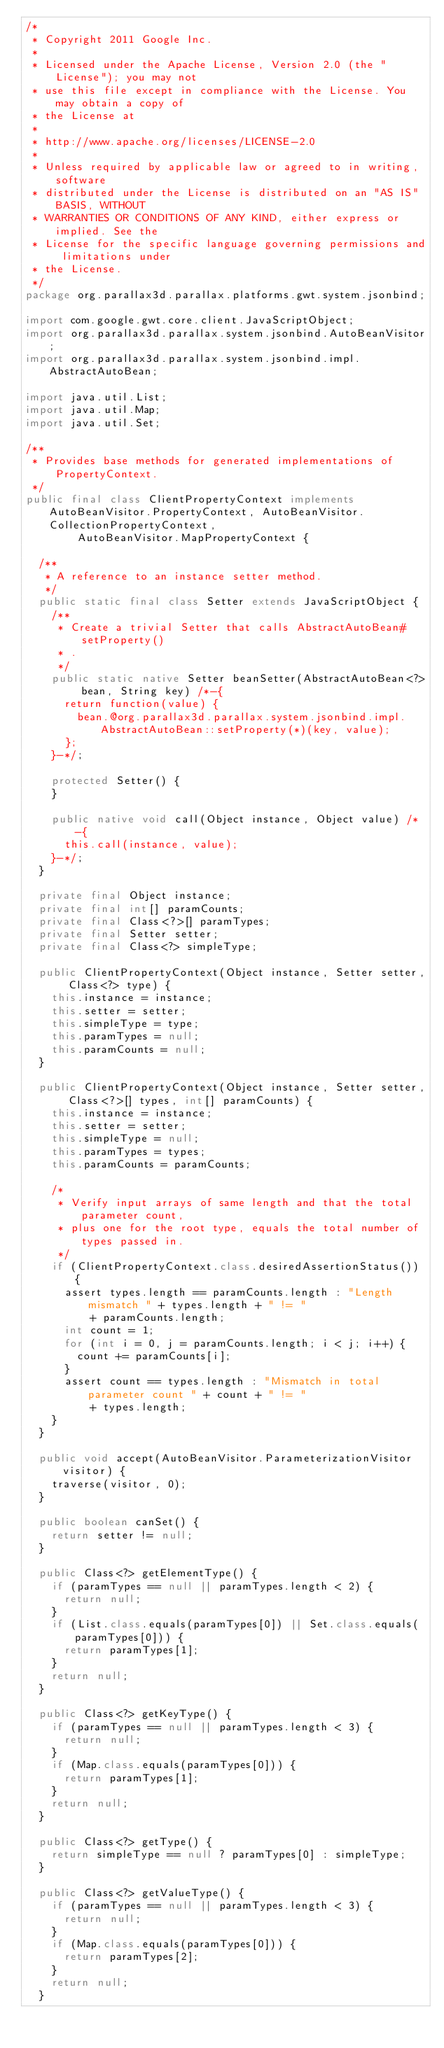Convert code to text. <code><loc_0><loc_0><loc_500><loc_500><_Java_>/*
 * Copyright 2011 Google Inc.
 *
 * Licensed under the Apache License, Version 2.0 (the "License"); you may not
 * use this file except in compliance with the License. You may obtain a copy of
 * the License at
 *
 * http://www.apache.org/licenses/LICENSE-2.0
 *
 * Unless required by applicable law or agreed to in writing, software
 * distributed under the License is distributed on an "AS IS" BASIS, WITHOUT
 * WARRANTIES OR CONDITIONS OF ANY KIND, either express or implied. See the
 * License for the specific language governing permissions and limitations under
 * the License.
 */
package org.parallax3d.parallax.platforms.gwt.system.jsonbind;

import com.google.gwt.core.client.JavaScriptObject;
import org.parallax3d.parallax.system.jsonbind.AutoBeanVisitor;
import org.parallax3d.parallax.system.jsonbind.impl.AbstractAutoBean;

import java.util.List;
import java.util.Map;
import java.util.Set;

/**
 * Provides base methods for generated implementations of PropertyContext.
 */
public final class ClientPropertyContext implements AutoBeanVisitor.PropertyContext, AutoBeanVisitor.CollectionPropertyContext,
        AutoBeanVisitor.MapPropertyContext {

  /**
   * A reference to an instance setter method.
   */
  public static final class Setter extends JavaScriptObject {
    /**
     * Create a trivial Setter that calls AbstractAutoBean#setProperty()
     * .
     */
    public static native Setter beanSetter(AbstractAutoBean<?> bean, String key) /*-{
      return function(value) {
        bean.@org.parallax3d.parallax.system.jsonbind.impl.AbstractAutoBean::setProperty(*)(key, value);
      };
    }-*/;

    protected Setter() {
    }

    public native void call(Object instance, Object value) /*-{
      this.call(instance, value);
    }-*/;
  }

  private final Object instance;
  private final int[] paramCounts;
  private final Class<?>[] paramTypes;
  private final Setter setter;
  private final Class<?> simpleType;

  public ClientPropertyContext(Object instance, Setter setter, Class<?> type) {
    this.instance = instance;
    this.setter = setter;
    this.simpleType = type;
    this.paramTypes = null;
    this.paramCounts = null;
  }

  public ClientPropertyContext(Object instance, Setter setter, Class<?>[] types, int[] paramCounts) {
    this.instance = instance;
    this.setter = setter;
    this.simpleType = null;
    this.paramTypes = types;
    this.paramCounts = paramCounts;

    /*
     * Verify input arrays of same length and that the total parameter count,
     * plus one for the root type, equals the total number of types passed in.
     */
    if (ClientPropertyContext.class.desiredAssertionStatus()) {
      assert types.length == paramCounts.length : "Length mismatch " + types.length + " != "
          + paramCounts.length;
      int count = 1;
      for (int i = 0, j = paramCounts.length; i < j; i++) {
        count += paramCounts[i];
      }
      assert count == types.length : "Mismatch in total parameter count " + count + " != "
          + types.length;
    }
  }

  public void accept(AutoBeanVisitor.ParameterizationVisitor visitor) {
    traverse(visitor, 0);
  }

  public boolean canSet() {
    return setter != null;
  }

  public Class<?> getElementType() {
    if (paramTypes == null || paramTypes.length < 2) {
      return null;
    }
    if (List.class.equals(paramTypes[0]) || Set.class.equals(paramTypes[0])) {
      return paramTypes[1];
    }
    return null;
  }

  public Class<?> getKeyType() {
    if (paramTypes == null || paramTypes.length < 3) {
      return null;
    }
    if (Map.class.equals(paramTypes[0])) {
      return paramTypes[1];
    }
    return null;
  }

  public Class<?> getType() {
    return simpleType == null ? paramTypes[0] : simpleType;
  }

  public Class<?> getValueType() {
    if (paramTypes == null || paramTypes.length < 3) {
      return null;
    }
    if (Map.class.equals(paramTypes[0])) {
      return paramTypes[2];
    }
    return null;
  }
</code> 